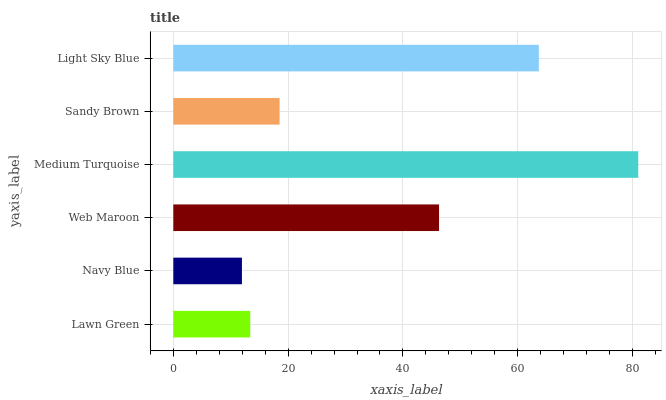Is Navy Blue the minimum?
Answer yes or no. Yes. Is Medium Turquoise the maximum?
Answer yes or no. Yes. Is Web Maroon the minimum?
Answer yes or no. No. Is Web Maroon the maximum?
Answer yes or no. No. Is Web Maroon greater than Navy Blue?
Answer yes or no. Yes. Is Navy Blue less than Web Maroon?
Answer yes or no. Yes. Is Navy Blue greater than Web Maroon?
Answer yes or no. No. Is Web Maroon less than Navy Blue?
Answer yes or no. No. Is Web Maroon the high median?
Answer yes or no. Yes. Is Sandy Brown the low median?
Answer yes or no. Yes. Is Navy Blue the high median?
Answer yes or no. No. Is Web Maroon the low median?
Answer yes or no. No. 